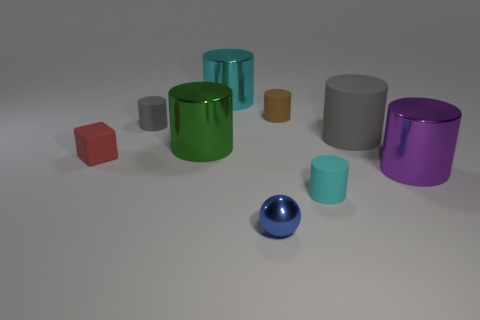There is a red object; is its size the same as the object in front of the cyan matte object?
Offer a terse response. Yes. What number of tiny objects are either gray cylinders or cyan metal objects?
Ensure brevity in your answer.  1. Is the number of green shiny cylinders greater than the number of large metal cylinders?
Make the answer very short. No. There is a gray rubber object left of the metallic thing in front of the big purple cylinder; what number of shiny spheres are in front of it?
Keep it short and to the point. 1. The tiny cyan rubber object has what shape?
Keep it short and to the point. Cylinder. How many other objects are there of the same material as the big gray cylinder?
Make the answer very short. 4. Is the size of the green thing the same as the cube?
Offer a terse response. No. There is a gray thing that is on the right side of the small cyan rubber cylinder; what is its shape?
Keep it short and to the point. Cylinder. There is a big metal object that is behind the metallic cylinder that is to the left of the large cyan object; what is its color?
Ensure brevity in your answer.  Cyan. There is a large object behind the large gray matte cylinder; does it have the same shape as the gray object that is left of the green metallic thing?
Offer a very short reply. Yes. 